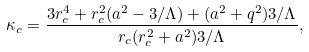<formula> <loc_0><loc_0><loc_500><loc_500>\kappa _ { c } = \frac { 3 r _ { c } ^ { 4 } + r _ { c } ^ { 2 } ( a ^ { 2 } - 3 / \Lambda ) + ( a ^ { 2 } + q ^ { 2 } ) 3 / \Lambda } { r _ { c } ( r _ { c } ^ { 2 } + a ^ { 2 } ) 3 / \Lambda } ,</formula> 